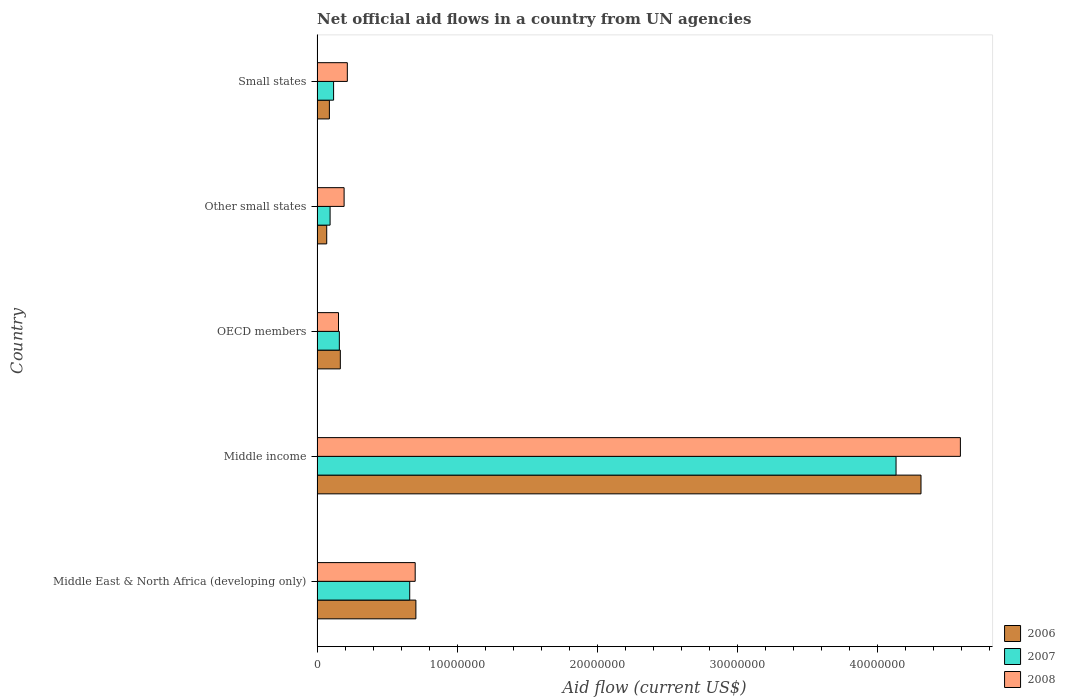Are the number of bars per tick equal to the number of legend labels?
Give a very brief answer. Yes. Are the number of bars on each tick of the Y-axis equal?
Ensure brevity in your answer.  Yes. How many bars are there on the 5th tick from the bottom?
Give a very brief answer. 3. What is the label of the 2nd group of bars from the top?
Ensure brevity in your answer.  Other small states. What is the net official aid flow in 2006 in Small states?
Make the answer very short. 8.80e+05. Across all countries, what is the maximum net official aid flow in 2008?
Offer a very short reply. 4.59e+07. Across all countries, what is the minimum net official aid flow in 2008?
Give a very brief answer. 1.53e+06. In which country was the net official aid flow in 2006 maximum?
Your response must be concise. Middle income. In which country was the net official aid flow in 2006 minimum?
Your answer should be very brief. Other small states. What is the total net official aid flow in 2006 in the graph?
Provide a short and direct response. 5.34e+07. What is the difference between the net official aid flow in 2007 in Middle East & North Africa (developing only) and that in Small states?
Your answer should be compact. 5.43e+06. What is the difference between the net official aid flow in 2006 in Other small states and the net official aid flow in 2008 in Small states?
Give a very brief answer. -1.47e+06. What is the average net official aid flow in 2008 per country?
Your response must be concise. 1.17e+07. What is the difference between the net official aid flow in 2008 and net official aid flow in 2006 in Middle income?
Your answer should be compact. 2.81e+06. What is the ratio of the net official aid flow in 2007 in Middle East & North Africa (developing only) to that in Other small states?
Provide a short and direct response. 7.11. Is the net official aid flow in 2007 in Middle East & North Africa (developing only) less than that in Other small states?
Your answer should be compact. No. What is the difference between the highest and the second highest net official aid flow in 2007?
Your answer should be very brief. 3.47e+07. What is the difference between the highest and the lowest net official aid flow in 2008?
Ensure brevity in your answer.  4.44e+07. Is the sum of the net official aid flow in 2008 in Middle income and Small states greater than the maximum net official aid flow in 2006 across all countries?
Ensure brevity in your answer.  Yes. What does the 2nd bar from the top in Other small states represents?
Offer a terse response. 2007. Is it the case that in every country, the sum of the net official aid flow in 2006 and net official aid flow in 2008 is greater than the net official aid flow in 2007?
Your response must be concise. Yes. Are all the bars in the graph horizontal?
Your answer should be compact. Yes. Are the values on the major ticks of X-axis written in scientific E-notation?
Offer a very short reply. No. Does the graph contain grids?
Ensure brevity in your answer.  No. Where does the legend appear in the graph?
Ensure brevity in your answer.  Bottom right. How many legend labels are there?
Ensure brevity in your answer.  3. What is the title of the graph?
Your response must be concise. Net official aid flows in a country from UN agencies. What is the label or title of the Y-axis?
Make the answer very short. Country. What is the Aid flow (current US$) of 2006 in Middle East & North Africa (developing only)?
Keep it short and to the point. 7.05e+06. What is the Aid flow (current US$) of 2007 in Middle East & North Africa (developing only)?
Your answer should be very brief. 6.61e+06. What is the Aid flow (current US$) in 2008 in Middle East & North Africa (developing only)?
Offer a very short reply. 7.00e+06. What is the Aid flow (current US$) of 2006 in Middle income?
Make the answer very short. 4.31e+07. What is the Aid flow (current US$) in 2007 in Middle income?
Make the answer very short. 4.13e+07. What is the Aid flow (current US$) of 2008 in Middle income?
Offer a terse response. 4.59e+07. What is the Aid flow (current US$) of 2006 in OECD members?
Offer a terse response. 1.66e+06. What is the Aid flow (current US$) of 2007 in OECD members?
Provide a short and direct response. 1.59e+06. What is the Aid flow (current US$) of 2008 in OECD members?
Your answer should be compact. 1.53e+06. What is the Aid flow (current US$) of 2006 in Other small states?
Your response must be concise. 6.90e+05. What is the Aid flow (current US$) in 2007 in Other small states?
Give a very brief answer. 9.30e+05. What is the Aid flow (current US$) in 2008 in Other small states?
Offer a very short reply. 1.93e+06. What is the Aid flow (current US$) in 2006 in Small states?
Give a very brief answer. 8.80e+05. What is the Aid flow (current US$) in 2007 in Small states?
Give a very brief answer. 1.18e+06. What is the Aid flow (current US$) in 2008 in Small states?
Make the answer very short. 2.16e+06. Across all countries, what is the maximum Aid flow (current US$) of 2006?
Provide a succinct answer. 4.31e+07. Across all countries, what is the maximum Aid flow (current US$) in 2007?
Your response must be concise. 4.13e+07. Across all countries, what is the maximum Aid flow (current US$) in 2008?
Your answer should be very brief. 4.59e+07. Across all countries, what is the minimum Aid flow (current US$) of 2006?
Your response must be concise. 6.90e+05. Across all countries, what is the minimum Aid flow (current US$) in 2007?
Make the answer very short. 9.30e+05. Across all countries, what is the minimum Aid flow (current US$) of 2008?
Provide a succinct answer. 1.53e+06. What is the total Aid flow (current US$) of 2006 in the graph?
Give a very brief answer. 5.34e+07. What is the total Aid flow (current US$) of 2007 in the graph?
Offer a terse response. 5.16e+07. What is the total Aid flow (current US$) in 2008 in the graph?
Offer a very short reply. 5.85e+07. What is the difference between the Aid flow (current US$) of 2006 in Middle East & North Africa (developing only) and that in Middle income?
Your answer should be compact. -3.60e+07. What is the difference between the Aid flow (current US$) of 2007 in Middle East & North Africa (developing only) and that in Middle income?
Give a very brief answer. -3.47e+07. What is the difference between the Aid flow (current US$) of 2008 in Middle East & North Africa (developing only) and that in Middle income?
Provide a succinct answer. -3.89e+07. What is the difference between the Aid flow (current US$) in 2006 in Middle East & North Africa (developing only) and that in OECD members?
Ensure brevity in your answer.  5.39e+06. What is the difference between the Aid flow (current US$) of 2007 in Middle East & North Africa (developing only) and that in OECD members?
Offer a terse response. 5.02e+06. What is the difference between the Aid flow (current US$) of 2008 in Middle East & North Africa (developing only) and that in OECD members?
Offer a very short reply. 5.47e+06. What is the difference between the Aid flow (current US$) of 2006 in Middle East & North Africa (developing only) and that in Other small states?
Your answer should be very brief. 6.36e+06. What is the difference between the Aid flow (current US$) in 2007 in Middle East & North Africa (developing only) and that in Other small states?
Provide a succinct answer. 5.68e+06. What is the difference between the Aid flow (current US$) in 2008 in Middle East & North Africa (developing only) and that in Other small states?
Make the answer very short. 5.07e+06. What is the difference between the Aid flow (current US$) of 2006 in Middle East & North Africa (developing only) and that in Small states?
Make the answer very short. 6.17e+06. What is the difference between the Aid flow (current US$) in 2007 in Middle East & North Africa (developing only) and that in Small states?
Provide a short and direct response. 5.43e+06. What is the difference between the Aid flow (current US$) of 2008 in Middle East & North Africa (developing only) and that in Small states?
Your answer should be compact. 4.84e+06. What is the difference between the Aid flow (current US$) in 2006 in Middle income and that in OECD members?
Ensure brevity in your answer.  4.14e+07. What is the difference between the Aid flow (current US$) in 2007 in Middle income and that in OECD members?
Your answer should be very brief. 3.97e+07. What is the difference between the Aid flow (current US$) of 2008 in Middle income and that in OECD members?
Ensure brevity in your answer.  4.44e+07. What is the difference between the Aid flow (current US$) in 2006 in Middle income and that in Other small states?
Ensure brevity in your answer.  4.24e+07. What is the difference between the Aid flow (current US$) of 2007 in Middle income and that in Other small states?
Ensure brevity in your answer.  4.04e+07. What is the difference between the Aid flow (current US$) in 2008 in Middle income and that in Other small states?
Keep it short and to the point. 4.40e+07. What is the difference between the Aid flow (current US$) in 2006 in Middle income and that in Small states?
Give a very brief answer. 4.22e+07. What is the difference between the Aid flow (current US$) of 2007 in Middle income and that in Small states?
Your response must be concise. 4.01e+07. What is the difference between the Aid flow (current US$) of 2008 in Middle income and that in Small states?
Provide a short and direct response. 4.37e+07. What is the difference between the Aid flow (current US$) of 2006 in OECD members and that in Other small states?
Provide a succinct answer. 9.70e+05. What is the difference between the Aid flow (current US$) of 2008 in OECD members and that in Other small states?
Your response must be concise. -4.00e+05. What is the difference between the Aid flow (current US$) in 2006 in OECD members and that in Small states?
Your answer should be compact. 7.80e+05. What is the difference between the Aid flow (current US$) in 2007 in OECD members and that in Small states?
Offer a terse response. 4.10e+05. What is the difference between the Aid flow (current US$) of 2008 in OECD members and that in Small states?
Provide a succinct answer. -6.30e+05. What is the difference between the Aid flow (current US$) of 2006 in Other small states and that in Small states?
Keep it short and to the point. -1.90e+05. What is the difference between the Aid flow (current US$) of 2008 in Other small states and that in Small states?
Ensure brevity in your answer.  -2.30e+05. What is the difference between the Aid flow (current US$) of 2006 in Middle East & North Africa (developing only) and the Aid flow (current US$) of 2007 in Middle income?
Provide a succinct answer. -3.42e+07. What is the difference between the Aid flow (current US$) in 2006 in Middle East & North Africa (developing only) and the Aid flow (current US$) in 2008 in Middle income?
Your response must be concise. -3.88e+07. What is the difference between the Aid flow (current US$) in 2007 in Middle East & North Africa (developing only) and the Aid flow (current US$) in 2008 in Middle income?
Your answer should be very brief. -3.93e+07. What is the difference between the Aid flow (current US$) of 2006 in Middle East & North Africa (developing only) and the Aid flow (current US$) of 2007 in OECD members?
Your answer should be very brief. 5.46e+06. What is the difference between the Aid flow (current US$) in 2006 in Middle East & North Africa (developing only) and the Aid flow (current US$) in 2008 in OECD members?
Keep it short and to the point. 5.52e+06. What is the difference between the Aid flow (current US$) in 2007 in Middle East & North Africa (developing only) and the Aid flow (current US$) in 2008 in OECD members?
Offer a very short reply. 5.08e+06. What is the difference between the Aid flow (current US$) of 2006 in Middle East & North Africa (developing only) and the Aid flow (current US$) of 2007 in Other small states?
Make the answer very short. 6.12e+06. What is the difference between the Aid flow (current US$) in 2006 in Middle East & North Africa (developing only) and the Aid flow (current US$) in 2008 in Other small states?
Your response must be concise. 5.12e+06. What is the difference between the Aid flow (current US$) in 2007 in Middle East & North Africa (developing only) and the Aid flow (current US$) in 2008 in Other small states?
Your answer should be compact. 4.68e+06. What is the difference between the Aid flow (current US$) of 2006 in Middle East & North Africa (developing only) and the Aid flow (current US$) of 2007 in Small states?
Your answer should be compact. 5.87e+06. What is the difference between the Aid flow (current US$) in 2006 in Middle East & North Africa (developing only) and the Aid flow (current US$) in 2008 in Small states?
Keep it short and to the point. 4.89e+06. What is the difference between the Aid flow (current US$) of 2007 in Middle East & North Africa (developing only) and the Aid flow (current US$) of 2008 in Small states?
Your response must be concise. 4.45e+06. What is the difference between the Aid flow (current US$) of 2006 in Middle income and the Aid flow (current US$) of 2007 in OECD members?
Your answer should be compact. 4.15e+07. What is the difference between the Aid flow (current US$) in 2006 in Middle income and the Aid flow (current US$) in 2008 in OECD members?
Your answer should be very brief. 4.16e+07. What is the difference between the Aid flow (current US$) in 2007 in Middle income and the Aid flow (current US$) in 2008 in OECD members?
Your answer should be compact. 3.98e+07. What is the difference between the Aid flow (current US$) of 2006 in Middle income and the Aid flow (current US$) of 2007 in Other small states?
Make the answer very short. 4.22e+07. What is the difference between the Aid flow (current US$) of 2006 in Middle income and the Aid flow (current US$) of 2008 in Other small states?
Your answer should be very brief. 4.12e+07. What is the difference between the Aid flow (current US$) of 2007 in Middle income and the Aid flow (current US$) of 2008 in Other small states?
Your answer should be compact. 3.94e+07. What is the difference between the Aid flow (current US$) in 2006 in Middle income and the Aid flow (current US$) in 2007 in Small states?
Provide a short and direct response. 4.19e+07. What is the difference between the Aid flow (current US$) of 2006 in Middle income and the Aid flow (current US$) of 2008 in Small states?
Offer a terse response. 4.09e+07. What is the difference between the Aid flow (current US$) in 2007 in Middle income and the Aid flow (current US$) in 2008 in Small states?
Offer a terse response. 3.91e+07. What is the difference between the Aid flow (current US$) in 2006 in OECD members and the Aid flow (current US$) in 2007 in Other small states?
Provide a short and direct response. 7.30e+05. What is the difference between the Aid flow (current US$) of 2006 in OECD members and the Aid flow (current US$) of 2008 in Other small states?
Offer a very short reply. -2.70e+05. What is the difference between the Aid flow (current US$) in 2007 in OECD members and the Aid flow (current US$) in 2008 in Other small states?
Make the answer very short. -3.40e+05. What is the difference between the Aid flow (current US$) of 2006 in OECD members and the Aid flow (current US$) of 2008 in Small states?
Your answer should be compact. -5.00e+05. What is the difference between the Aid flow (current US$) in 2007 in OECD members and the Aid flow (current US$) in 2008 in Small states?
Your answer should be very brief. -5.70e+05. What is the difference between the Aid flow (current US$) in 2006 in Other small states and the Aid flow (current US$) in 2007 in Small states?
Make the answer very short. -4.90e+05. What is the difference between the Aid flow (current US$) in 2006 in Other small states and the Aid flow (current US$) in 2008 in Small states?
Offer a very short reply. -1.47e+06. What is the difference between the Aid flow (current US$) in 2007 in Other small states and the Aid flow (current US$) in 2008 in Small states?
Your response must be concise. -1.23e+06. What is the average Aid flow (current US$) of 2006 per country?
Provide a short and direct response. 1.07e+07. What is the average Aid flow (current US$) of 2007 per country?
Your response must be concise. 1.03e+07. What is the average Aid flow (current US$) of 2008 per country?
Make the answer very short. 1.17e+07. What is the difference between the Aid flow (current US$) in 2006 and Aid flow (current US$) in 2008 in Middle East & North Africa (developing only)?
Your answer should be compact. 5.00e+04. What is the difference between the Aid flow (current US$) in 2007 and Aid flow (current US$) in 2008 in Middle East & North Africa (developing only)?
Provide a short and direct response. -3.90e+05. What is the difference between the Aid flow (current US$) in 2006 and Aid flow (current US$) in 2007 in Middle income?
Give a very brief answer. 1.78e+06. What is the difference between the Aid flow (current US$) of 2006 and Aid flow (current US$) of 2008 in Middle income?
Offer a terse response. -2.81e+06. What is the difference between the Aid flow (current US$) of 2007 and Aid flow (current US$) of 2008 in Middle income?
Keep it short and to the point. -4.59e+06. What is the difference between the Aid flow (current US$) of 2006 and Aid flow (current US$) of 2007 in OECD members?
Your response must be concise. 7.00e+04. What is the difference between the Aid flow (current US$) in 2006 and Aid flow (current US$) in 2007 in Other small states?
Your answer should be very brief. -2.40e+05. What is the difference between the Aid flow (current US$) of 2006 and Aid flow (current US$) of 2008 in Other small states?
Ensure brevity in your answer.  -1.24e+06. What is the difference between the Aid flow (current US$) of 2006 and Aid flow (current US$) of 2007 in Small states?
Provide a short and direct response. -3.00e+05. What is the difference between the Aid flow (current US$) of 2006 and Aid flow (current US$) of 2008 in Small states?
Offer a terse response. -1.28e+06. What is the difference between the Aid flow (current US$) of 2007 and Aid flow (current US$) of 2008 in Small states?
Provide a short and direct response. -9.80e+05. What is the ratio of the Aid flow (current US$) of 2006 in Middle East & North Africa (developing only) to that in Middle income?
Your answer should be very brief. 0.16. What is the ratio of the Aid flow (current US$) of 2007 in Middle East & North Africa (developing only) to that in Middle income?
Keep it short and to the point. 0.16. What is the ratio of the Aid flow (current US$) of 2008 in Middle East & North Africa (developing only) to that in Middle income?
Your answer should be very brief. 0.15. What is the ratio of the Aid flow (current US$) of 2006 in Middle East & North Africa (developing only) to that in OECD members?
Ensure brevity in your answer.  4.25. What is the ratio of the Aid flow (current US$) in 2007 in Middle East & North Africa (developing only) to that in OECD members?
Give a very brief answer. 4.16. What is the ratio of the Aid flow (current US$) of 2008 in Middle East & North Africa (developing only) to that in OECD members?
Provide a succinct answer. 4.58. What is the ratio of the Aid flow (current US$) in 2006 in Middle East & North Africa (developing only) to that in Other small states?
Your answer should be compact. 10.22. What is the ratio of the Aid flow (current US$) of 2007 in Middle East & North Africa (developing only) to that in Other small states?
Offer a very short reply. 7.11. What is the ratio of the Aid flow (current US$) in 2008 in Middle East & North Africa (developing only) to that in Other small states?
Your answer should be compact. 3.63. What is the ratio of the Aid flow (current US$) in 2006 in Middle East & North Africa (developing only) to that in Small states?
Ensure brevity in your answer.  8.01. What is the ratio of the Aid flow (current US$) of 2007 in Middle East & North Africa (developing only) to that in Small states?
Your answer should be very brief. 5.6. What is the ratio of the Aid flow (current US$) of 2008 in Middle East & North Africa (developing only) to that in Small states?
Your answer should be compact. 3.24. What is the ratio of the Aid flow (current US$) in 2006 in Middle income to that in OECD members?
Make the answer very short. 25.95. What is the ratio of the Aid flow (current US$) of 2007 in Middle income to that in OECD members?
Keep it short and to the point. 25.97. What is the ratio of the Aid flow (current US$) in 2008 in Middle income to that in OECD members?
Provide a succinct answer. 29.99. What is the ratio of the Aid flow (current US$) of 2006 in Middle income to that in Other small states?
Make the answer very short. 62.43. What is the ratio of the Aid flow (current US$) in 2007 in Middle income to that in Other small states?
Make the answer very short. 44.41. What is the ratio of the Aid flow (current US$) in 2008 in Middle income to that in Other small states?
Your answer should be very brief. 23.78. What is the ratio of the Aid flow (current US$) in 2006 in Middle income to that in Small states?
Keep it short and to the point. 48.95. What is the ratio of the Aid flow (current US$) in 2008 in Middle income to that in Small states?
Provide a short and direct response. 21.25. What is the ratio of the Aid flow (current US$) of 2006 in OECD members to that in Other small states?
Provide a short and direct response. 2.41. What is the ratio of the Aid flow (current US$) in 2007 in OECD members to that in Other small states?
Provide a short and direct response. 1.71. What is the ratio of the Aid flow (current US$) in 2008 in OECD members to that in Other small states?
Offer a very short reply. 0.79. What is the ratio of the Aid flow (current US$) in 2006 in OECD members to that in Small states?
Provide a short and direct response. 1.89. What is the ratio of the Aid flow (current US$) of 2007 in OECD members to that in Small states?
Provide a short and direct response. 1.35. What is the ratio of the Aid flow (current US$) of 2008 in OECD members to that in Small states?
Your answer should be compact. 0.71. What is the ratio of the Aid flow (current US$) in 2006 in Other small states to that in Small states?
Offer a very short reply. 0.78. What is the ratio of the Aid flow (current US$) in 2007 in Other small states to that in Small states?
Provide a short and direct response. 0.79. What is the ratio of the Aid flow (current US$) of 2008 in Other small states to that in Small states?
Provide a succinct answer. 0.89. What is the difference between the highest and the second highest Aid flow (current US$) in 2006?
Ensure brevity in your answer.  3.60e+07. What is the difference between the highest and the second highest Aid flow (current US$) in 2007?
Ensure brevity in your answer.  3.47e+07. What is the difference between the highest and the second highest Aid flow (current US$) of 2008?
Your response must be concise. 3.89e+07. What is the difference between the highest and the lowest Aid flow (current US$) of 2006?
Keep it short and to the point. 4.24e+07. What is the difference between the highest and the lowest Aid flow (current US$) in 2007?
Keep it short and to the point. 4.04e+07. What is the difference between the highest and the lowest Aid flow (current US$) in 2008?
Keep it short and to the point. 4.44e+07. 